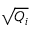Convert formula to latex. <formula><loc_0><loc_0><loc_500><loc_500>\sqrt { Q _ { i } }</formula> 